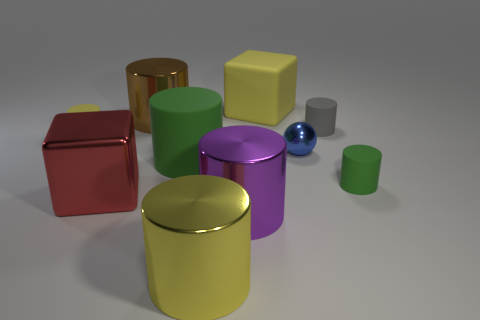Are there fewer large yellow shiny cylinders on the right side of the yellow rubber cube than purple shiny objects?
Your answer should be compact. Yes. The yellow matte thing that is the same shape as the gray thing is what size?
Your answer should be very brief. Small. How many large green cylinders are made of the same material as the tiny blue sphere?
Give a very brief answer. 0. Do the block behind the tiny green cylinder and the small gray cylinder have the same material?
Provide a short and direct response. Yes. Are there the same number of brown cylinders that are in front of the gray cylinder and green metal cubes?
Offer a very short reply. Yes. What size is the metallic sphere?
Give a very brief answer. Small. What material is the big thing that is the same color as the matte block?
Give a very brief answer. Metal. How many big shiny cylinders have the same color as the rubber block?
Your answer should be compact. 1. Does the gray matte object have the same size as the yellow cube?
Ensure brevity in your answer.  No. What size is the yellow block to the right of the big cube that is in front of the small green thing?
Keep it short and to the point. Large. 